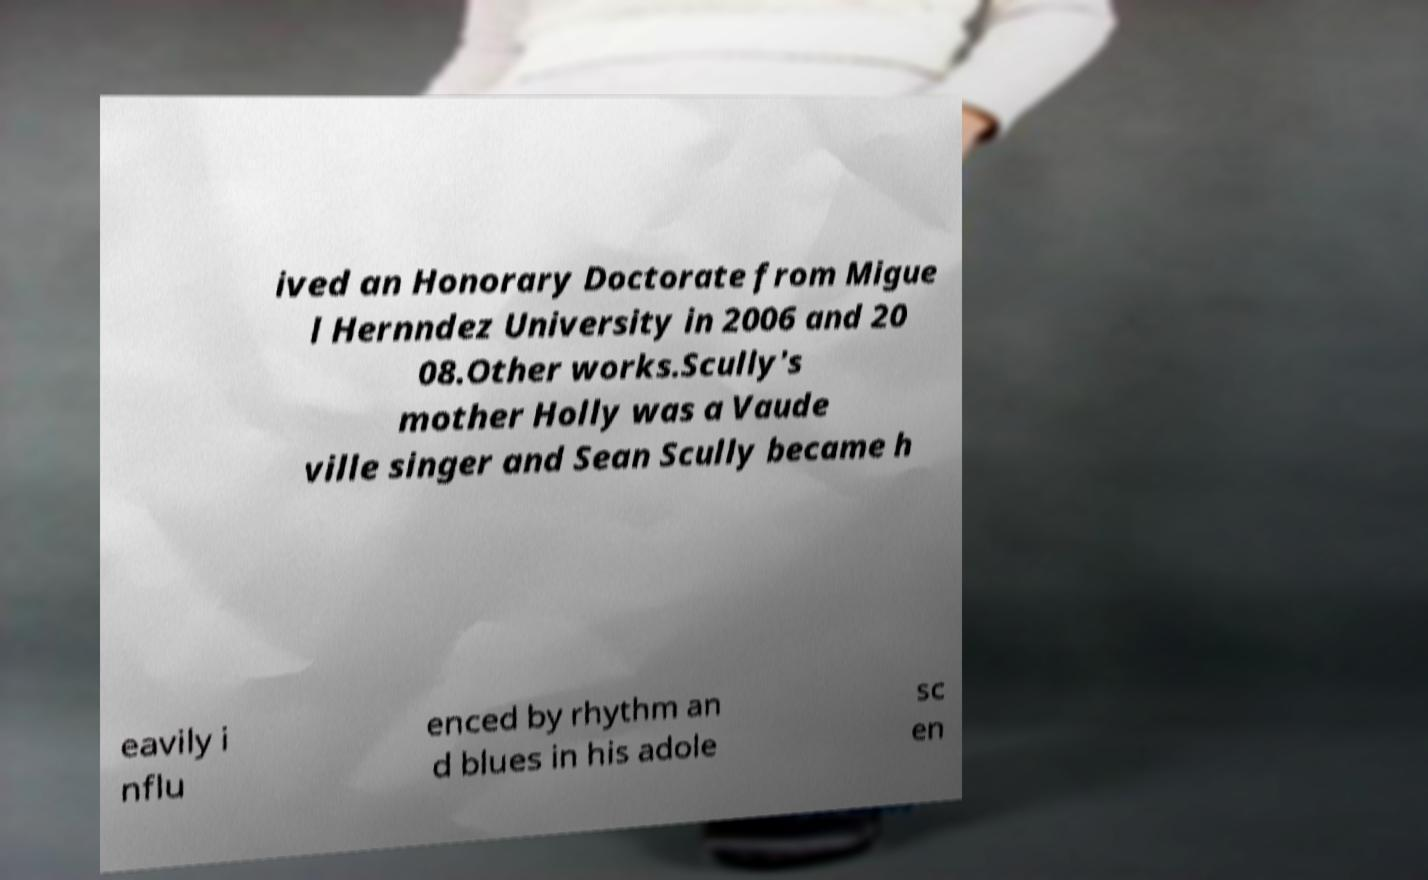Could you assist in decoding the text presented in this image and type it out clearly? ived an Honorary Doctorate from Migue l Hernndez University in 2006 and 20 08.Other works.Scully's mother Holly was a Vaude ville singer and Sean Scully became h eavily i nflu enced by rhythm an d blues in his adole sc en 